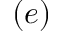Convert formula to latex. <formula><loc_0><loc_0><loc_500><loc_500>( e )</formula> 